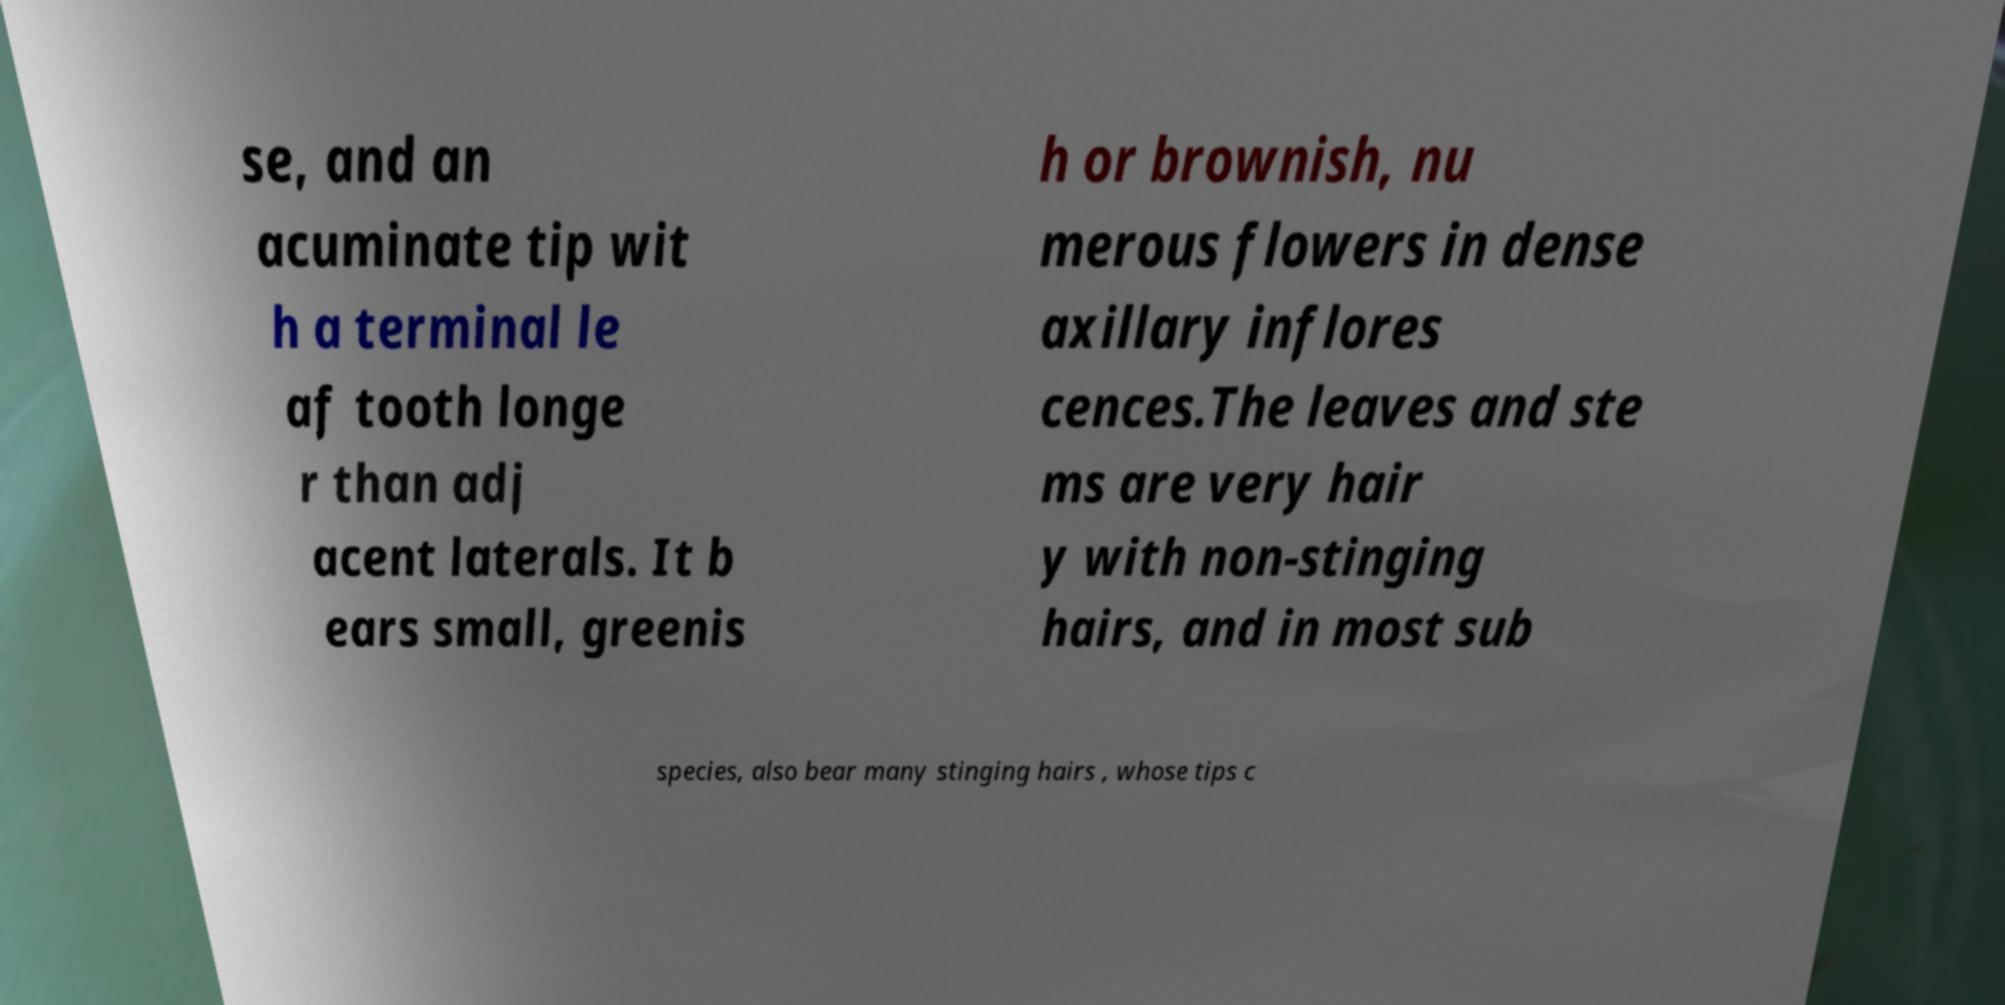Can you read and provide the text displayed in the image?This photo seems to have some interesting text. Can you extract and type it out for me? se, and an acuminate tip wit h a terminal le af tooth longe r than adj acent laterals. It b ears small, greenis h or brownish, nu merous flowers in dense axillary inflores cences.The leaves and ste ms are very hair y with non-stinging hairs, and in most sub species, also bear many stinging hairs , whose tips c 